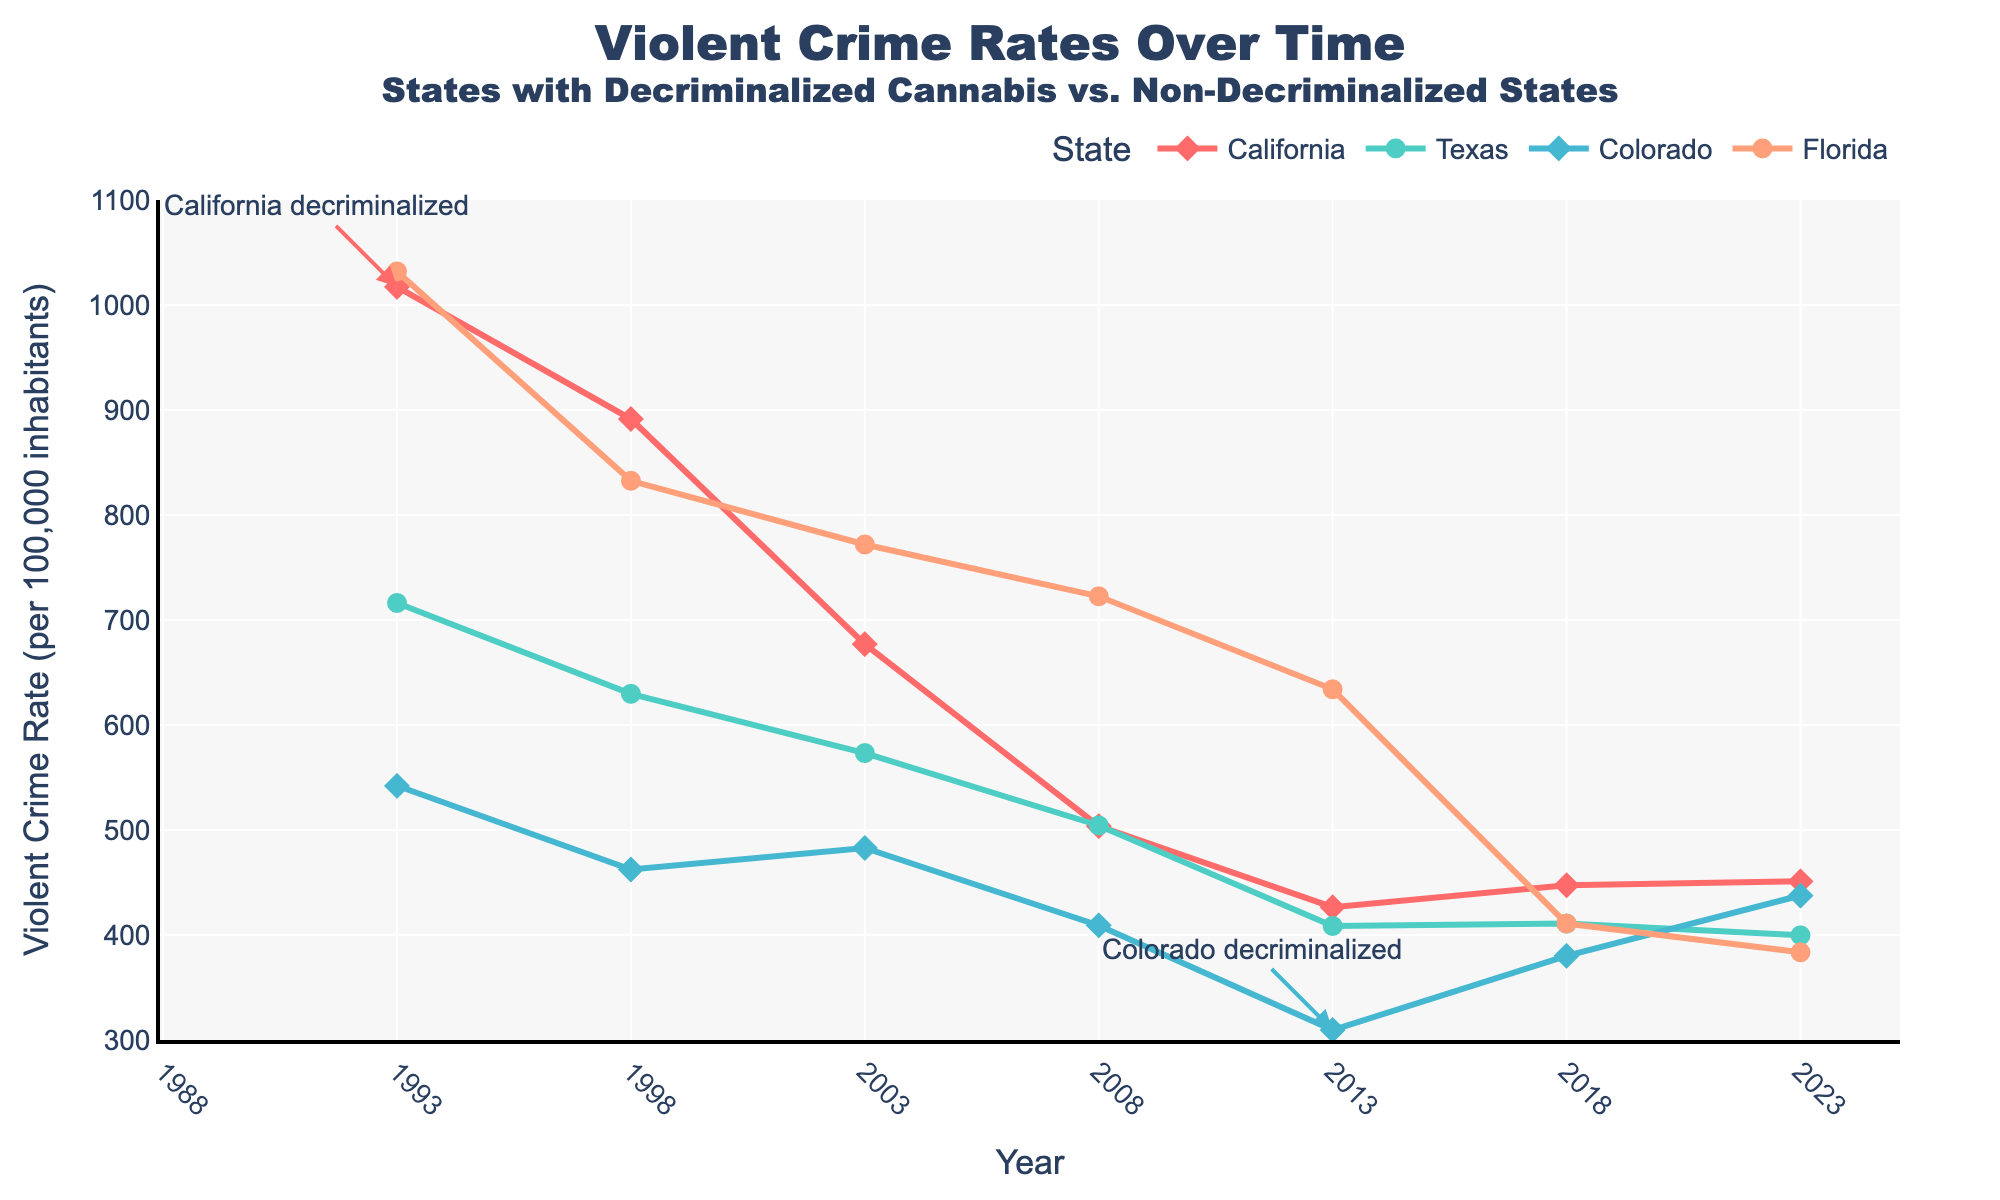When did Colorado decriminalize cannabis? The plot shows annotations indicating the year a state decriminalized cannabis. For Colorado, the annotation shows it decriminalized cannabis in 2013.
Answer: 2013 Which state had the highest violent crime rate in 1993? By looking at the plot for the year 1993, California has the highest violent crime rate compared to Texas, Colorado, and Florida.
Answer: California How did the violent crime rate in Texas change from 2008 to 2023? From observing the plot for Texas from 2008 to 2023, the violent crime rate declined from 504.3 to 399.7. The difference can be calculated as 504.3 - 399.7 = 104.6.
Answer: Decreased by 104.6 Compare the violent crime rate in California and Florida in 1993. Which state had a higher rate? By looking at 1993, both California and Florida appear to have high crime rates, but California is slightly lower (1017.3) compared to Florida (1032.0).
Answer: Florida, higher What is the trend of violent crime rates in states that have decriminalized cannabis? For states like California and Colorado, the general trend after decriminalization shows a decrease, followed by some fluctuations. For instance, California shows a decrease until 2013 then slight fluctuations; Colorado shows a decrease till 2013 with a rising trend after.
Answer: Decrease followed by slight fluctuations What is the violent crime rate of California in 2013 compared to Texas in 2013? In 2013, California’s violent crime rate is 426.5, while Texas has a rate of 408.6. Comparing the two, California’s rate is slightly higher.
Answer: California, higher Which year did California have the lowest violent crime rate? By observing the line for California, the lowest violent crime rate is in 2013 at 426.5.
Answer: 2013 Identify the general trend in violent crime rates in Florida from 1993 to 2023. Observing the plot, Florida's violent crime rate shows a consistent decline from 1993 (1032.0) to 2023 (383.5).
Answer: Declining What is the general trend of violent crime rates in states that have not decriminalized cannabis? Observing states like Florida and Texas, which have not decriminalized cannabis, the general trend shows a steady decline in violent crime rates from 1993 to 2023.
Answer: Steady decline 